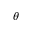<formula> <loc_0><loc_0><loc_500><loc_500>\theta</formula> 